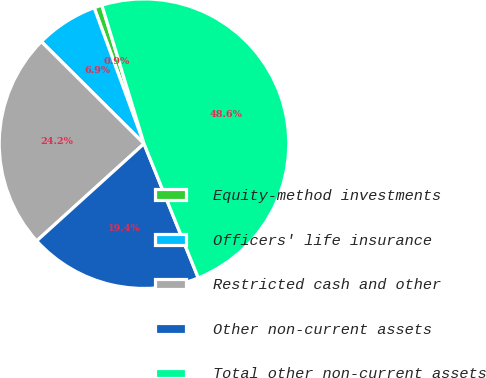<chart> <loc_0><loc_0><loc_500><loc_500><pie_chart><fcel>Equity-method investments<fcel>Officers' life insurance<fcel>Restricted cash and other<fcel>Other non-current assets<fcel>Total other non-current assets<nl><fcel>0.89%<fcel>6.95%<fcel>24.17%<fcel>19.4%<fcel>48.59%<nl></chart> 